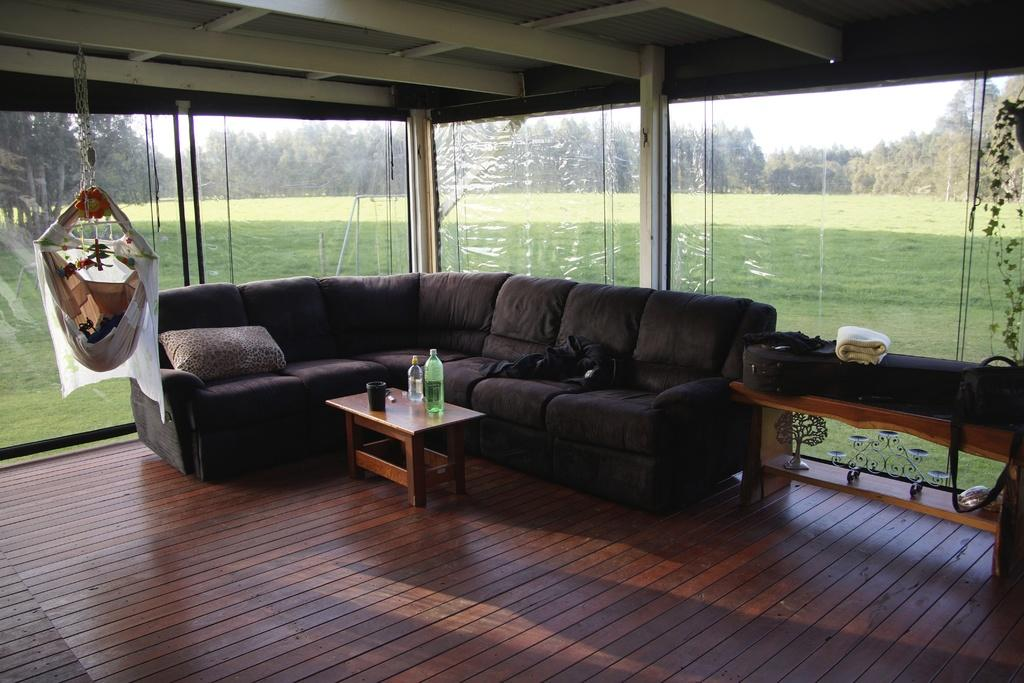What type of furniture is in the image? There is a sofa bed in the image. What objects are on the table in the image? There are bottles on a table in the image. What type of living organism is in the image? There is a plant in the image. What can be seen through the window in the image? Trees are visible through a window in the image. What type of wood is used to make the pan in the image? There is no pan present in the image. What level of difficulty is associated with the plant in the image? The image does not provide information about the difficulty level of the plant. 